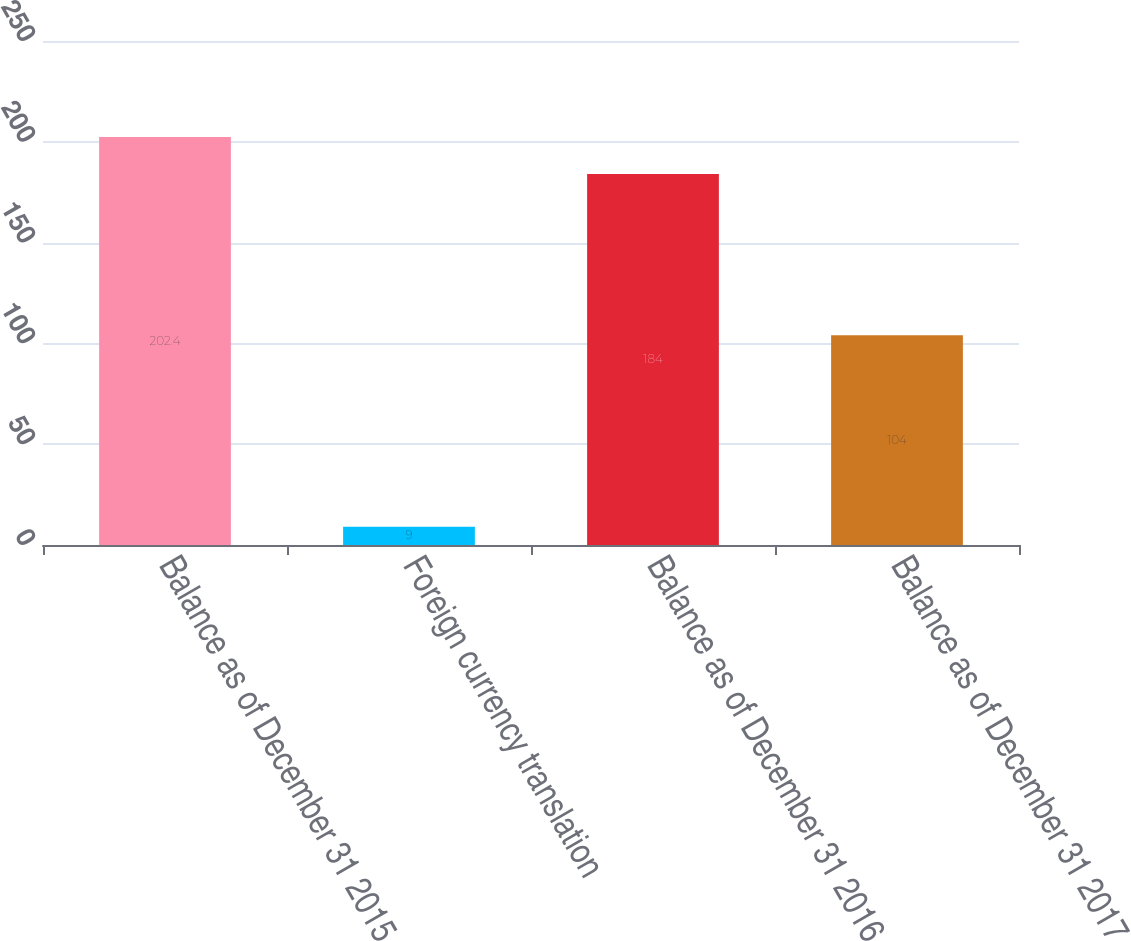Convert chart to OTSL. <chart><loc_0><loc_0><loc_500><loc_500><bar_chart><fcel>Balance as of December 31 2015<fcel>Foreign currency translation<fcel>Balance as of December 31 2016<fcel>Balance as of December 31 2017<nl><fcel>202.4<fcel>9<fcel>184<fcel>104<nl></chart> 